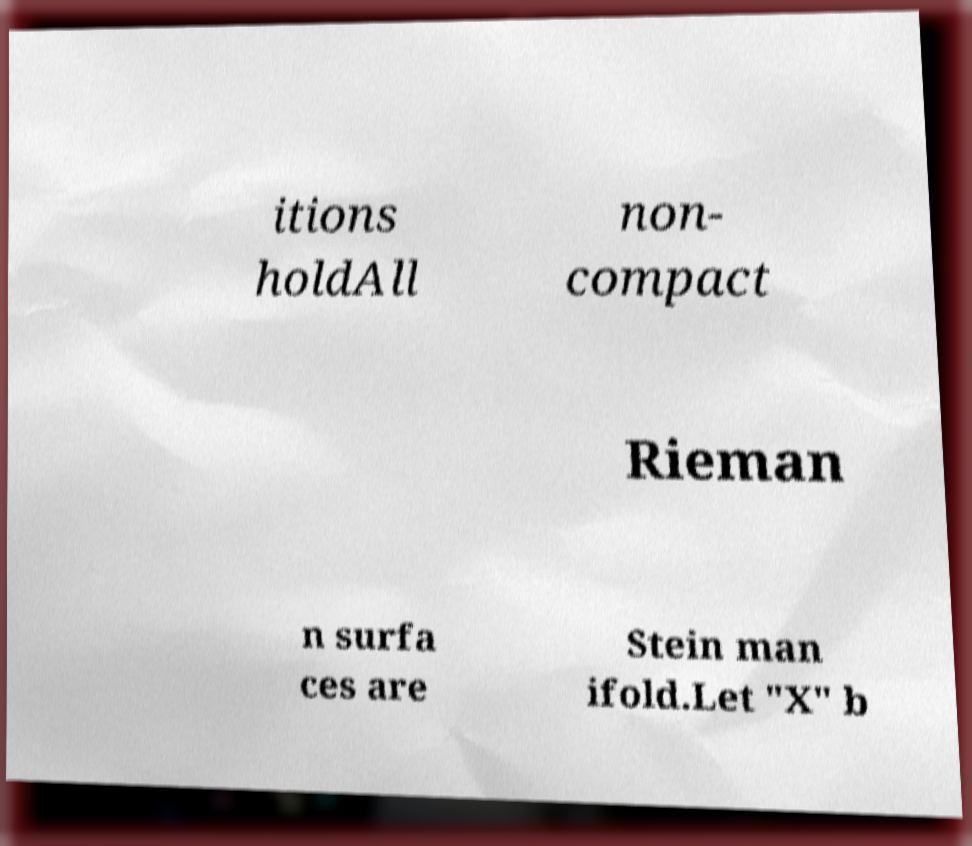Could you extract and type out the text from this image? itions holdAll non- compact Rieman n surfa ces are Stein man ifold.Let "X" b 